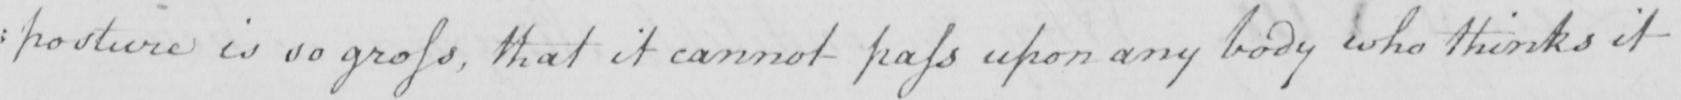Please transcribe the handwritten text in this image. : posture is so gross , that it cannot pass upon any body who thinks it 